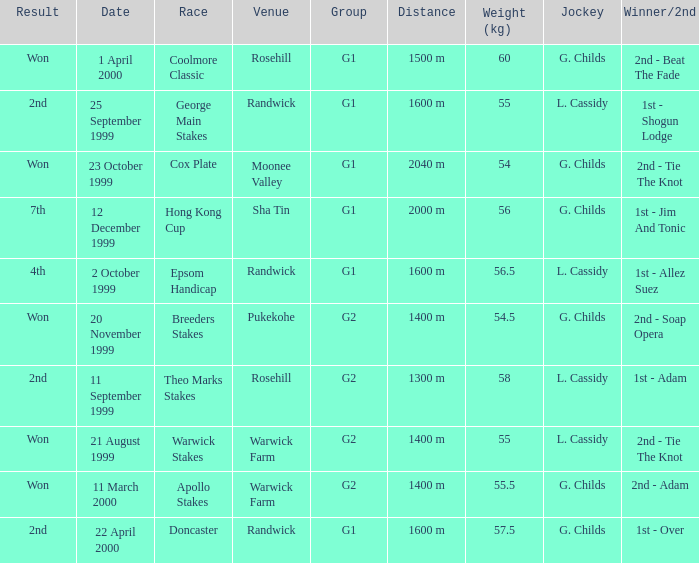List the weight for 56 kilograms. 2000 m. Can you give me this table as a dict? {'header': ['Result', 'Date', 'Race', 'Venue', 'Group', 'Distance', 'Weight (kg)', 'Jockey', 'Winner/2nd'], 'rows': [['Won', '1 April 2000', 'Coolmore Classic', 'Rosehill', 'G1', '1500 m', '60', 'G. Childs', '2nd - Beat The Fade'], ['2nd', '25 September 1999', 'George Main Stakes', 'Randwick', 'G1', '1600 m', '55', 'L. Cassidy', '1st - Shogun Lodge'], ['Won', '23 October 1999', 'Cox Plate', 'Moonee Valley', 'G1', '2040 m', '54', 'G. Childs', '2nd - Tie The Knot'], ['7th', '12 December 1999', 'Hong Kong Cup', 'Sha Tin', 'G1', '2000 m', '56', 'G. Childs', '1st - Jim And Tonic'], ['4th', '2 October 1999', 'Epsom Handicap', 'Randwick', 'G1', '1600 m', '56.5', 'L. Cassidy', '1st - Allez Suez'], ['Won', '20 November 1999', 'Breeders Stakes', 'Pukekohe', 'G2', '1400 m', '54.5', 'G. Childs', '2nd - Soap Opera'], ['2nd', '11 September 1999', 'Theo Marks Stakes', 'Rosehill', 'G2', '1300 m', '58', 'L. Cassidy', '1st - Adam'], ['Won', '21 August 1999', 'Warwick Stakes', 'Warwick Farm', 'G2', '1400 m', '55', 'L. Cassidy', '2nd - Tie The Knot'], ['Won', '11 March 2000', 'Apollo Stakes', 'Warwick Farm', 'G2', '1400 m', '55.5', 'G. Childs', '2nd - Adam'], ['2nd', '22 April 2000', 'Doncaster', 'Randwick', 'G1', '1600 m', '57.5', 'G. Childs', '1st - Over']]} 